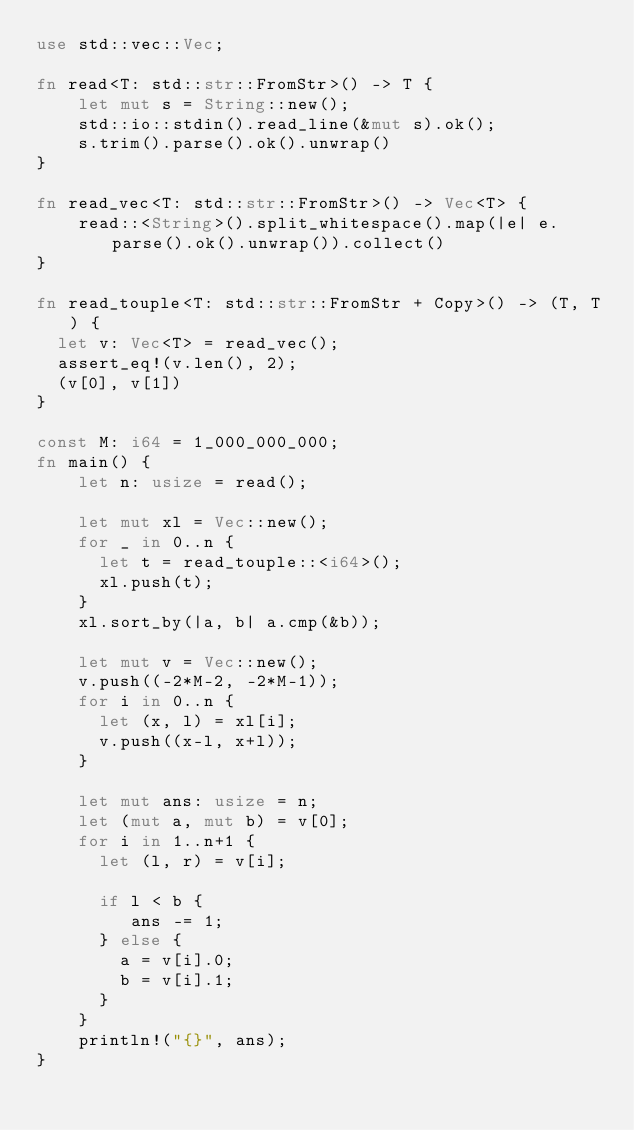<code> <loc_0><loc_0><loc_500><loc_500><_Rust_>use std::vec::Vec;

fn read<T: std::str::FromStr>() -> T {
    let mut s = String::new();
    std::io::stdin().read_line(&mut s).ok();
    s.trim().parse().ok().unwrap()
}

fn read_vec<T: std::str::FromStr>() -> Vec<T> {
    read::<String>().split_whitespace().map(|e| e.parse().ok().unwrap()).collect()
}

fn read_touple<T: std::str::FromStr + Copy>() -> (T, T) {
  let v: Vec<T> = read_vec();
  assert_eq!(v.len(), 2);
  (v[0], v[1])
}

const M: i64 = 1_000_000_000;
fn main() {
    let n: usize = read();

    let mut xl = Vec::new();
    for _ in 0..n {
      let t = read_touple::<i64>();
      xl.push(t);
    }
    xl.sort_by(|a, b| a.cmp(&b));

    let mut v = Vec::new();
    v.push((-2*M-2, -2*M-1));
    for i in 0..n {
      let (x, l) = xl[i];
      v.push((x-l, x+l));
    }

    let mut ans: usize = n;
    let (mut a, mut b) = v[0];
    for i in 1..n+1 {
      let (l, r) = v[i];

      if l < b {
         ans -= 1;
      } else {
        a = v[i].0;
        b = v[i].1;
      }
    }
    println!("{}", ans);
}
</code> 